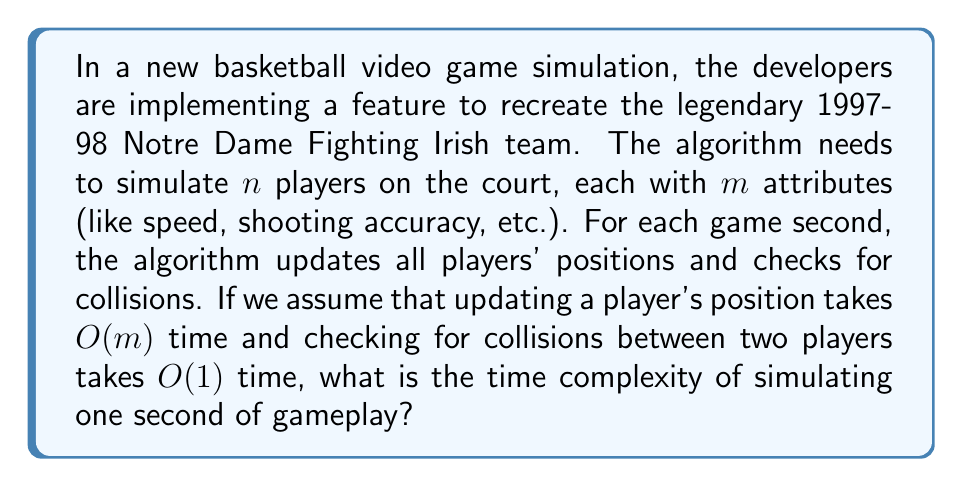Provide a solution to this math problem. Let's break this down step by step:

1) First, we need to update the positions of all $n$ players:
   - Each player has $m$ attributes
   - Updating one player takes $O(m)$ time
   - For $n$ players, this takes $O(nm)$ time

2) Next, we need to check for collisions:
   - We need to check each player against every other player
   - This is a combination problem: $\binom{n}{2} = \frac{n(n-1)}{2}$
   - Each collision check takes $O(1)$ time
   - So, collision checking takes $O(n^2)$ time

3) The total time for one second of gameplay is the sum of these two steps:
   $O(nm) + O(n^2)$

4) In Big O notation, we keep the term that grows the fastest. Here, it depends on the relative sizes of $m$ and $n$:
   - If $m > n$, then $O(nm)$ dominates
   - If $n > m$, then $O(n^2)$ dominates

5) To cover both cases, we express the final complexity as:
   $O(nm + n^2)$

This expression ensures that whichever term is larger will be the dominant factor in the time complexity.
Answer: $O(nm + n^2)$ 